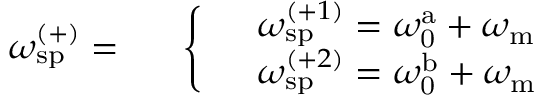Convert formula to latex. <formula><loc_0><loc_0><loc_500><loc_500>\omega _ { s p } ^ { ( + ) } = \begin{array} { r l } & { \left \{ \begin{array} { l l } & { \omega _ { s p } ^ { ( + 1 ) } = \omega _ { 0 } ^ { a } + \omega _ { m } } \\ & { \omega _ { s p } ^ { ( + 2 ) } = \omega _ { 0 } ^ { b } + \omega _ { m } } \end{array} } \end{array}</formula> 